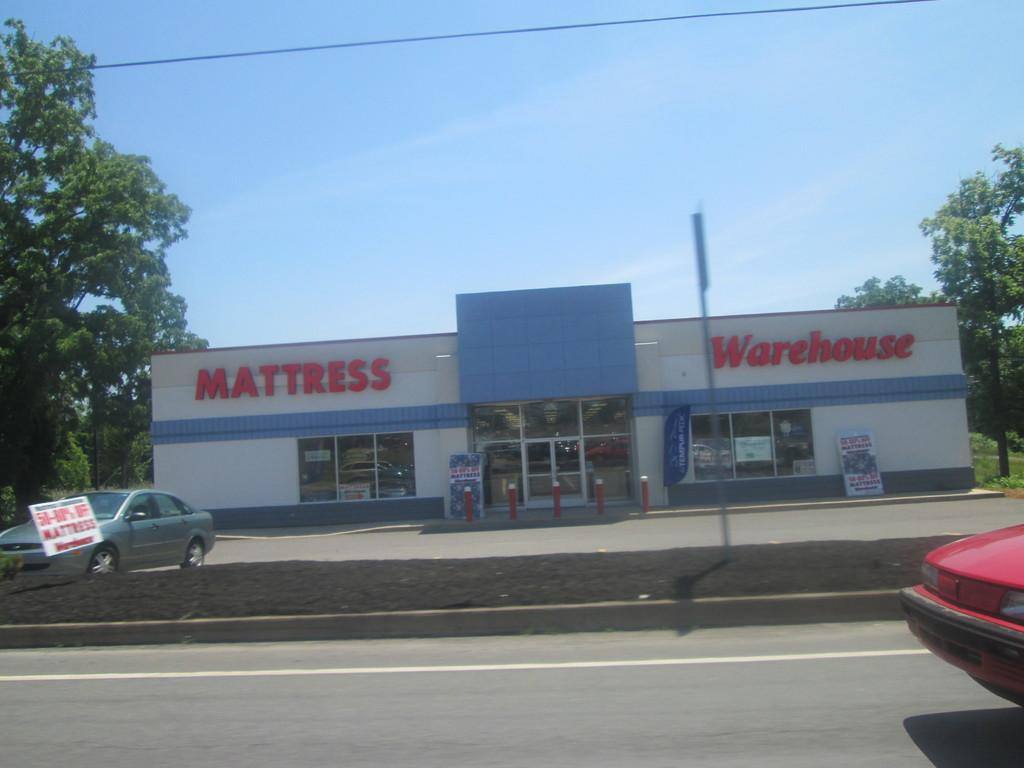What can be seen on the roads in the image? There are vehicles on the roads in the image. What objects are present in the image that support or hold something? There are poles and boards in the image. What type of establishment can be seen in the image? There is a store in the image. What else can be seen in the image that is related to infrastructure or communication? There are wires in the image. What type of natural elements are present in the image? There are trees in the image. What is visible in the background of the image? The sky is visible in the background of the image. What is the opinion of the cheese in the image? There is no cheese present in the image, so it is not possible to determine its opinion. Can you describe how the vehicles kick the ball in the image? There is no ball or kicking activity present in the image; it features vehicles on the roads. 